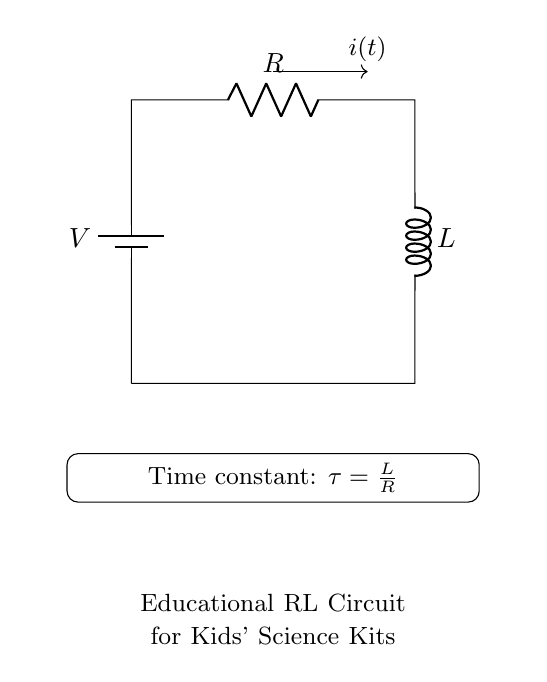What are the main components of this circuit? The circuit contains a battery, a resistor, and an inductor. Each of these components has a distinct role in the circuit: the battery provides voltage, the resistor limits current, and the inductor stores energy in a magnetic field.
Answer: battery, resistor, inductor What does the symbol "V" represent? The symbol "V" represents the voltage provided by the battery in the circuit. It is the source of electrical energy that drives the current through the resistor and inductor.
Answer: voltage What is the formula for the time constant in this circuit? The time constant, represented as tau, is calculated using the formula tau equals L divided by R, where L is the inductance and R is the resistance. This relationship helps understand how quickly the current will rise or fall in the circuit.
Answer: tau = L/R How does the current behave when the switch is first closed? When the switch is first closed, the current begins at zero and gradually increases to its maximum value, as determined by the voltage and resistance in the circuit. The rate of this increase is characterized by the time constant.
Answer: increases gradually What happens to the time constant if resistance is doubled? If the resistance is doubled, the time constant will be halved, according to the formula tau equals L divided by R. This means that the circuit will respond faster to changes in voltage.
Answer: halved What is the role of the inductor in this RL circuit? The inductor serves to store energy in the magnetic field when current flows through it, and it opposes changes in current. This creates a delay in the current building up when the voltage is applied.
Answer: stores energy 